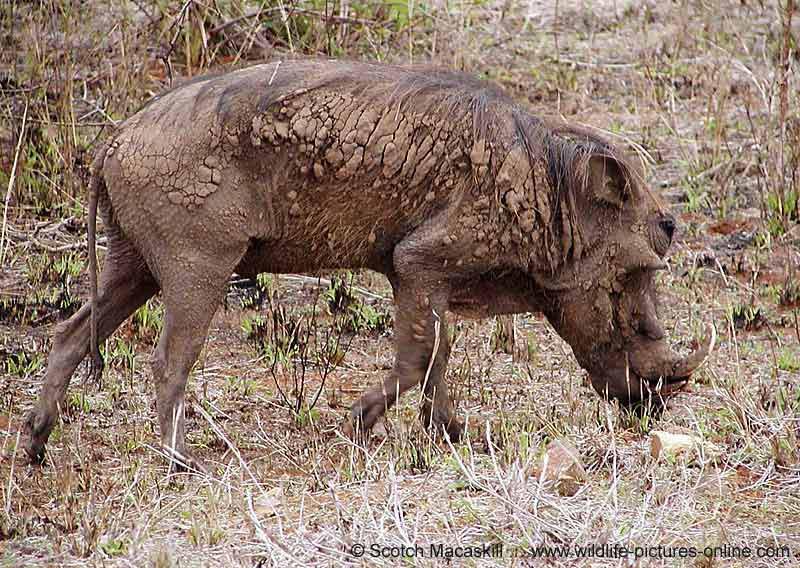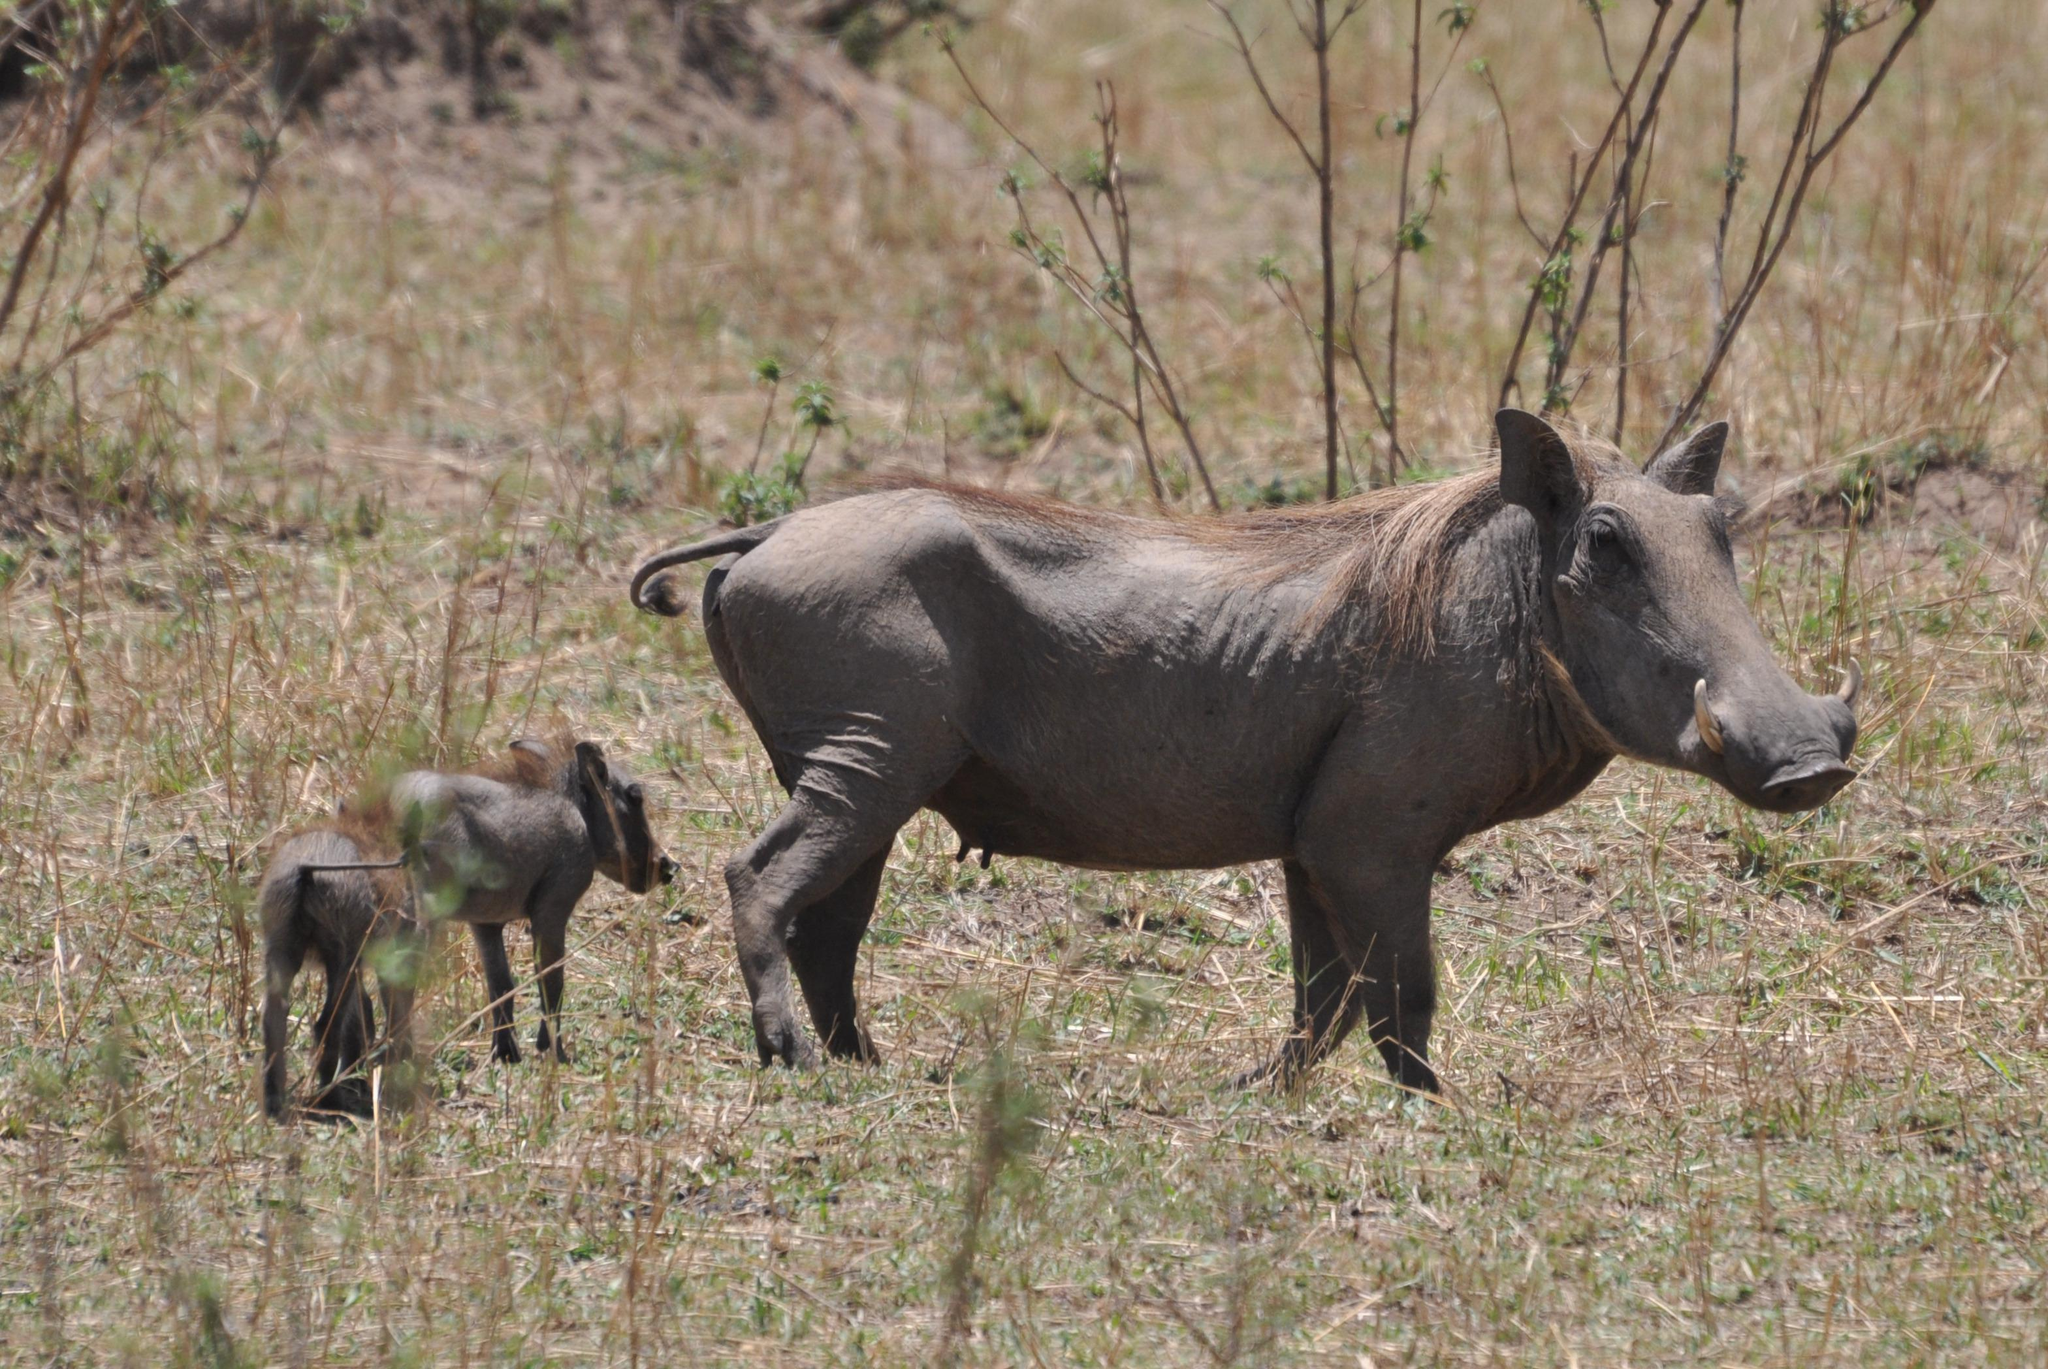The first image is the image on the left, the second image is the image on the right. Given the left and right images, does the statement "The right image contains one adult warthog that is standing beside two baby warthogs." hold true? Answer yes or no. Yes. The first image is the image on the left, the second image is the image on the right. For the images displayed, is the sentence "An image includes a wild cat and a warthog, and the action scene features kicked-up dust." factually correct? Answer yes or no. No. 